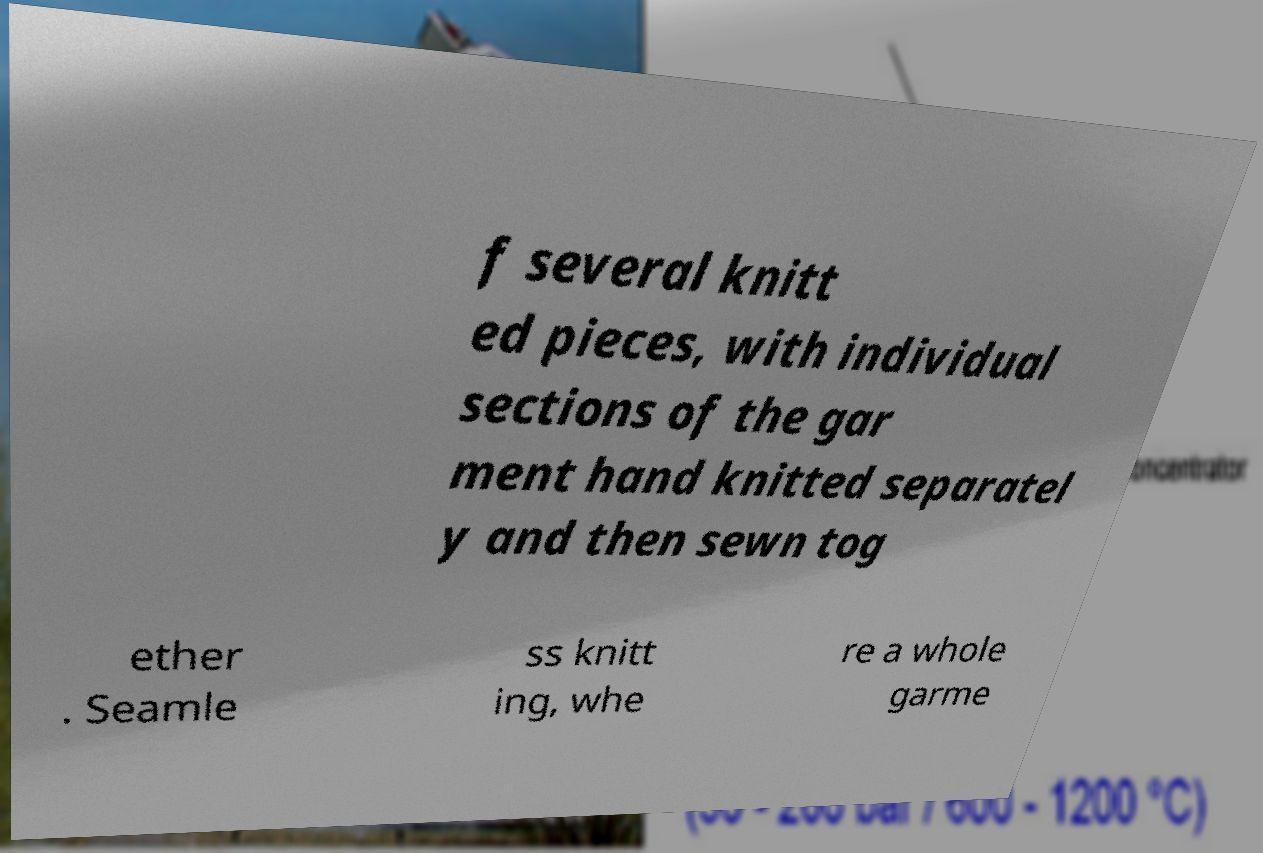Can you read and provide the text displayed in the image?This photo seems to have some interesting text. Can you extract and type it out for me? f several knitt ed pieces, with individual sections of the gar ment hand knitted separatel y and then sewn tog ether . Seamle ss knitt ing, whe re a whole garme 